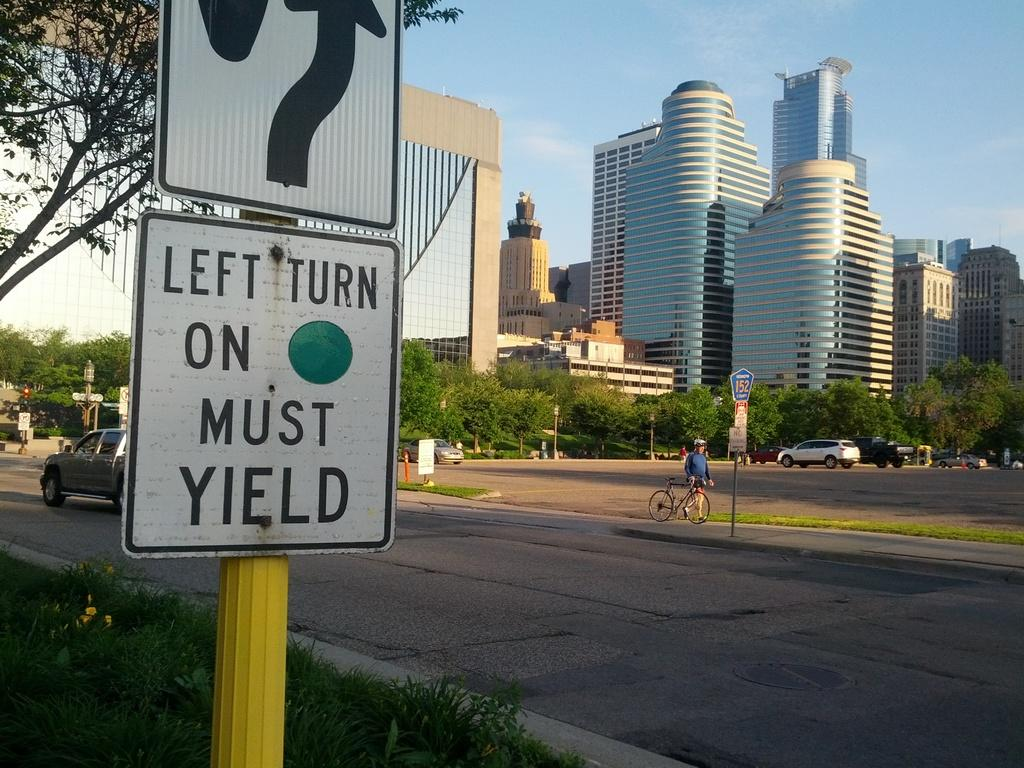<image>
Describe the image concisely. A sign says Left Turn on Green Must Yield. 